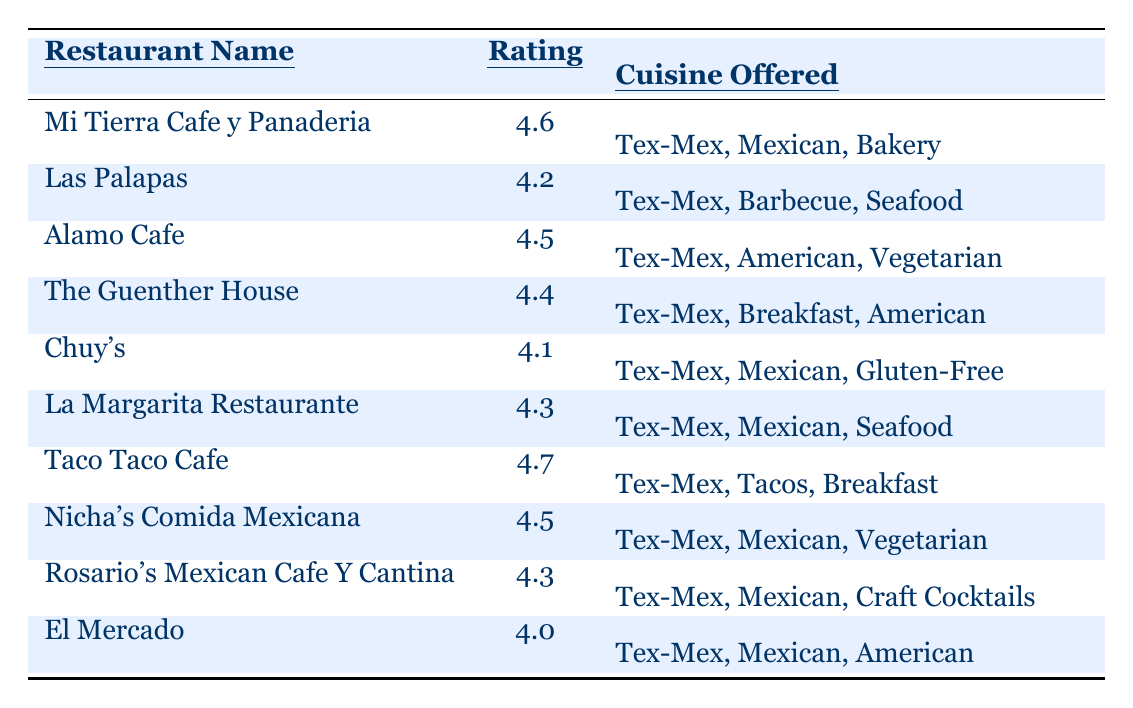What is the highest average rating among the Tex-Mex restaurants? The highest rating in the table is listed next to Taco Taco Cafe, which has an average rating of 4.7.
Answer: 4.7 Which restaurant has the lowest rating? By scanning the ratings, El Mercado has the lowest average rating at 4.0.
Answer: 4.0 How many restaurants offer Mexican cuisine? Counting the entries in the cuisine column, all restaurants except Taco Taco Cafe offer Mexican cuisine, totaling 9.
Answer: 9 What is the average rating of the Tex-Mex restaurants listed? To find the average, sum the ratings: (4.6 + 4.2 + 4.5 + 4.4 + 4.1 + 4.3 + 4.7 + 4.5 + 4.3 + 4.0) = 43.7, and there are 10 restaurants, so the average rating is 43.7 / 10 = 4.37.
Answer: 4.37 Is there a restaurant that has both vegetarian and seafood options? Checking the cuisines offered, there are no restaurants that have both vegetarian and seafood options listed together.
Answer: No Which restaurant offers breakfast cuisine with the highest rating? Taco Taco Cafe has the highest rating of 4.7 among restaurants offering breakfast cuisine.
Answer: Taco Taco Cafe How many restaurants have a rating of 4.3 or higher? The ratings that are 4.3 or higher are for Mi Tierra Cafe y Panaderia, Alamo Cafe, The Guenther House, Nicha's Comida Mexicana, Taco Taco Cafe, and La Margarita Restaurante, making a total of 7.
Answer: 7 Which cuisine is the most common among the listed restaurants? All restaurants offer Tex-Mex cuisine, confirming that it is the most common as every entry includes it.
Answer: Tex-Mex Are there any restaurants that offer both vegetarian options and have an average rating of 4.5 or higher? Yes, both Alamo Cafe and Nicha's Comida Mexicana offer vegetarian options and maintain ratings of 4.5.
Answer: Yes What is the total number of different cuisines offered by the restaurants? The unique cuisines listed in the restaurants are Tex-Mex, Mexican, Bakery, Barbecue, Seafood, American, Vegetarian, Breakfast, and Gluten-Free, totaling 9 different cuisines.
Answer: 9 